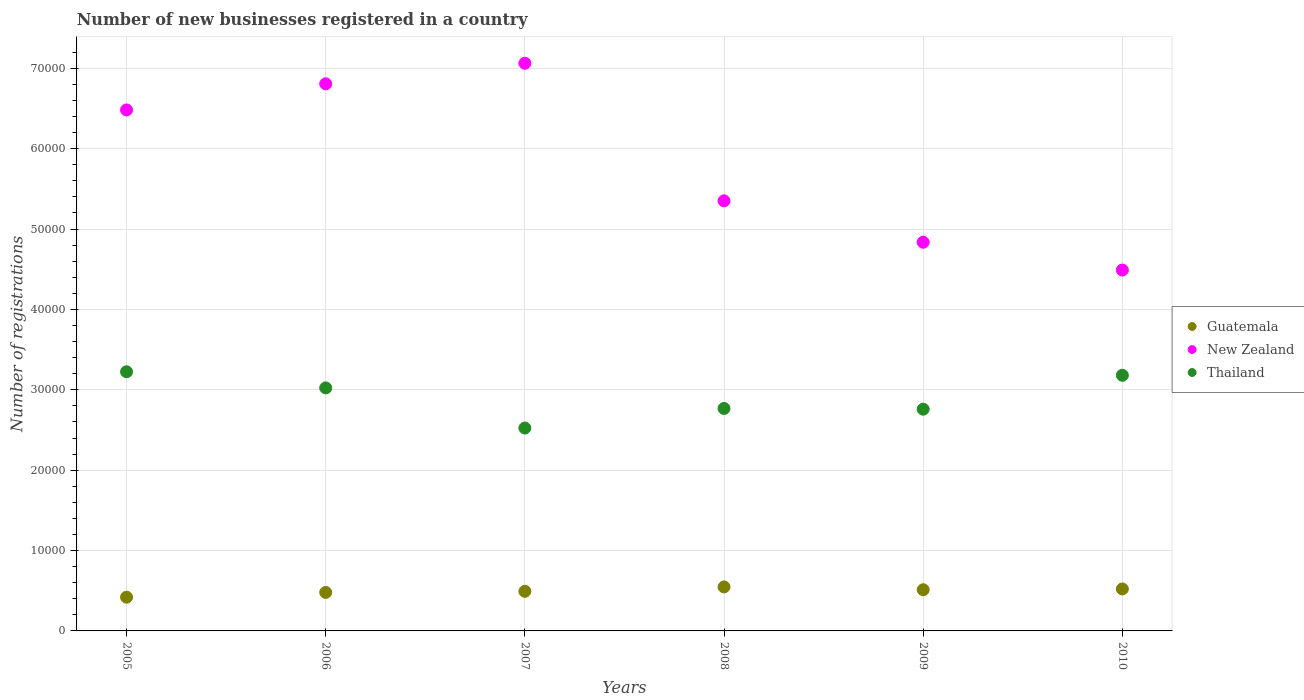How many different coloured dotlines are there?
Give a very brief answer. 3. What is the number of new businesses registered in New Zealand in 2007?
Your answer should be compact. 7.06e+04. Across all years, what is the maximum number of new businesses registered in Thailand?
Offer a very short reply. 3.22e+04. Across all years, what is the minimum number of new businesses registered in New Zealand?
Your answer should be compact. 4.49e+04. In which year was the number of new businesses registered in Thailand minimum?
Offer a terse response. 2007. What is the total number of new businesses registered in New Zealand in the graph?
Your answer should be very brief. 3.50e+05. What is the difference between the number of new businesses registered in Guatemala in 2005 and that in 2007?
Keep it short and to the point. -727. What is the difference between the number of new businesses registered in Thailand in 2010 and the number of new businesses registered in New Zealand in 2008?
Provide a succinct answer. -2.17e+04. What is the average number of new businesses registered in Guatemala per year?
Keep it short and to the point. 4956.17. In the year 2007, what is the difference between the number of new businesses registered in New Zealand and number of new businesses registered in Thailand?
Give a very brief answer. 4.54e+04. What is the ratio of the number of new businesses registered in Guatemala in 2005 to that in 2007?
Your answer should be compact. 0.85. Is the difference between the number of new businesses registered in New Zealand in 2007 and 2010 greater than the difference between the number of new businesses registered in Thailand in 2007 and 2010?
Your answer should be very brief. Yes. What is the difference between the highest and the second highest number of new businesses registered in New Zealand?
Your answer should be compact. 2553. What is the difference between the highest and the lowest number of new businesses registered in Thailand?
Provide a succinct answer. 7002. Is it the case that in every year, the sum of the number of new businesses registered in New Zealand and number of new businesses registered in Thailand  is greater than the number of new businesses registered in Guatemala?
Give a very brief answer. Yes. Does the graph contain any zero values?
Offer a very short reply. No. How are the legend labels stacked?
Give a very brief answer. Vertical. What is the title of the graph?
Offer a terse response. Number of new businesses registered in a country. What is the label or title of the X-axis?
Ensure brevity in your answer.  Years. What is the label or title of the Y-axis?
Ensure brevity in your answer.  Number of registrations. What is the Number of registrations of Guatemala in 2005?
Keep it short and to the point. 4198. What is the Number of registrations in New Zealand in 2005?
Keep it short and to the point. 6.48e+04. What is the Number of registrations of Thailand in 2005?
Make the answer very short. 3.22e+04. What is the Number of registrations of Guatemala in 2006?
Ensure brevity in your answer.  4790. What is the Number of registrations of New Zealand in 2006?
Provide a short and direct response. 6.81e+04. What is the Number of registrations of Thailand in 2006?
Offer a very short reply. 3.02e+04. What is the Number of registrations of Guatemala in 2007?
Ensure brevity in your answer.  4925. What is the Number of registrations of New Zealand in 2007?
Make the answer very short. 7.06e+04. What is the Number of registrations in Thailand in 2007?
Your response must be concise. 2.52e+04. What is the Number of registrations of Guatemala in 2008?
Keep it short and to the point. 5476. What is the Number of registrations in New Zealand in 2008?
Make the answer very short. 5.35e+04. What is the Number of registrations of Thailand in 2008?
Your answer should be compact. 2.77e+04. What is the Number of registrations of Guatemala in 2009?
Your answer should be compact. 5126. What is the Number of registrations in New Zealand in 2009?
Give a very brief answer. 4.84e+04. What is the Number of registrations in Thailand in 2009?
Your response must be concise. 2.76e+04. What is the Number of registrations in Guatemala in 2010?
Ensure brevity in your answer.  5222. What is the Number of registrations of New Zealand in 2010?
Give a very brief answer. 4.49e+04. What is the Number of registrations in Thailand in 2010?
Keep it short and to the point. 3.18e+04. Across all years, what is the maximum Number of registrations in Guatemala?
Make the answer very short. 5476. Across all years, what is the maximum Number of registrations in New Zealand?
Ensure brevity in your answer.  7.06e+04. Across all years, what is the maximum Number of registrations in Thailand?
Your answer should be very brief. 3.22e+04. Across all years, what is the minimum Number of registrations in Guatemala?
Offer a terse response. 4198. Across all years, what is the minimum Number of registrations of New Zealand?
Provide a short and direct response. 4.49e+04. Across all years, what is the minimum Number of registrations in Thailand?
Keep it short and to the point. 2.52e+04. What is the total Number of registrations in Guatemala in the graph?
Your answer should be compact. 2.97e+04. What is the total Number of registrations in New Zealand in the graph?
Offer a very short reply. 3.50e+05. What is the total Number of registrations in Thailand in the graph?
Give a very brief answer. 1.75e+05. What is the difference between the Number of registrations in Guatemala in 2005 and that in 2006?
Your answer should be compact. -592. What is the difference between the Number of registrations in New Zealand in 2005 and that in 2006?
Make the answer very short. -3253. What is the difference between the Number of registrations of Thailand in 2005 and that in 2006?
Make the answer very short. 2008. What is the difference between the Number of registrations of Guatemala in 2005 and that in 2007?
Offer a terse response. -727. What is the difference between the Number of registrations in New Zealand in 2005 and that in 2007?
Offer a terse response. -5806. What is the difference between the Number of registrations of Thailand in 2005 and that in 2007?
Offer a very short reply. 7002. What is the difference between the Number of registrations of Guatemala in 2005 and that in 2008?
Make the answer very short. -1278. What is the difference between the Number of registrations of New Zealand in 2005 and that in 2008?
Ensure brevity in your answer.  1.13e+04. What is the difference between the Number of registrations of Thailand in 2005 and that in 2008?
Ensure brevity in your answer.  4563. What is the difference between the Number of registrations of Guatemala in 2005 and that in 2009?
Offer a very short reply. -928. What is the difference between the Number of registrations in New Zealand in 2005 and that in 2009?
Provide a short and direct response. 1.65e+04. What is the difference between the Number of registrations in Thailand in 2005 and that in 2009?
Provide a short and direct response. 4656. What is the difference between the Number of registrations of Guatemala in 2005 and that in 2010?
Ensure brevity in your answer.  -1024. What is the difference between the Number of registrations of New Zealand in 2005 and that in 2010?
Make the answer very short. 1.99e+04. What is the difference between the Number of registrations of Thailand in 2005 and that in 2010?
Make the answer very short. 437. What is the difference between the Number of registrations of Guatemala in 2006 and that in 2007?
Your answer should be very brief. -135. What is the difference between the Number of registrations of New Zealand in 2006 and that in 2007?
Provide a succinct answer. -2553. What is the difference between the Number of registrations in Thailand in 2006 and that in 2007?
Your answer should be compact. 4994. What is the difference between the Number of registrations in Guatemala in 2006 and that in 2008?
Offer a very short reply. -686. What is the difference between the Number of registrations of New Zealand in 2006 and that in 2008?
Offer a very short reply. 1.46e+04. What is the difference between the Number of registrations of Thailand in 2006 and that in 2008?
Your answer should be very brief. 2555. What is the difference between the Number of registrations of Guatemala in 2006 and that in 2009?
Offer a very short reply. -336. What is the difference between the Number of registrations in New Zealand in 2006 and that in 2009?
Provide a short and direct response. 1.97e+04. What is the difference between the Number of registrations in Thailand in 2006 and that in 2009?
Provide a succinct answer. 2648. What is the difference between the Number of registrations of Guatemala in 2006 and that in 2010?
Keep it short and to the point. -432. What is the difference between the Number of registrations of New Zealand in 2006 and that in 2010?
Your answer should be compact. 2.32e+04. What is the difference between the Number of registrations in Thailand in 2006 and that in 2010?
Provide a succinct answer. -1571. What is the difference between the Number of registrations of Guatemala in 2007 and that in 2008?
Ensure brevity in your answer.  -551. What is the difference between the Number of registrations in New Zealand in 2007 and that in 2008?
Ensure brevity in your answer.  1.71e+04. What is the difference between the Number of registrations in Thailand in 2007 and that in 2008?
Make the answer very short. -2439. What is the difference between the Number of registrations of Guatemala in 2007 and that in 2009?
Give a very brief answer. -201. What is the difference between the Number of registrations of New Zealand in 2007 and that in 2009?
Give a very brief answer. 2.23e+04. What is the difference between the Number of registrations in Thailand in 2007 and that in 2009?
Your answer should be very brief. -2346. What is the difference between the Number of registrations in Guatemala in 2007 and that in 2010?
Ensure brevity in your answer.  -297. What is the difference between the Number of registrations of New Zealand in 2007 and that in 2010?
Give a very brief answer. 2.57e+04. What is the difference between the Number of registrations in Thailand in 2007 and that in 2010?
Your answer should be very brief. -6565. What is the difference between the Number of registrations of Guatemala in 2008 and that in 2009?
Give a very brief answer. 350. What is the difference between the Number of registrations in New Zealand in 2008 and that in 2009?
Make the answer very short. 5154. What is the difference between the Number of registrations in Thailand in 2008 and that in 2009?
Your response must be concise. 93. What is the difference between the Number of registrations of Guatemala in 2008 and that in 2010?
Keep it short and to the point. 254. What is the difference between the Number of registrations of New Zealand in 2008 and that in 2010?
Give a very brief answer. 8614. What is the difference between the Number of registrations in Thailand in 2008 and that in 2010?
Give a very brief answer. -4126. What is the difference between the Number of registrations of Guatemala in 2009 and that in 2010?
Make the answer very short. -96. What is the difference between the Number of registrations of New Zealand in 2009 and that in 2010?
Your response must be concise. 3460. What is the difference between the Number of registrations of Thailand in 2009 and that in 2010?
Your response must be concise. -4219. What is the difference between the Number of registrations in Guatemala in 2005 and the Number of registrations in New Zealand in 2006?
Make the answer very short. -6.39e+04. What is the difference between the Number of registrations in Guatemala in 2005 and the Number of registrations in Thailand in 2006?
Your answer should be very brief. -2.60e+04. What is the difference between the Number of registrations in New Zealand in 2005 and the Number of registrations in Thailand in 2006?
Give a very brief answer. 3.46e+04. What is the difference between the Number of registrations in Guatemala in 2005 and the Number of registrations in New Zealand in 2007?
Offer a terse response. -6.64e+04. What is the difference between the Number of registrations of Guatemala in 2005 and the Number of registrations of Thailand in 2007?
Ensure brevity in your answer.  -2.10e+04. What is the difference between the Number of registrations of New Zealand in 2005 and the Number of registrations of Thailand in 2007?
Your response must be concise. 3.96e+04. What is the difference between the Number of registrations in Guatemala in 2005 and the Number of registrations in New Zealand in 2008?
Make the answer very short. -4.93e+04. What is the difference between the Number of registrations in Guatemala in 2005 and the Number of registrations in Thailand in 2008?
Your answer should be compact. -2.35e+04. What is the difference between the Number of registrations of New Zealand in 2005 and the Number of registrations of Thailand in 2008?
Keep it short and to the point. 3.71e+04. What is the difference between the Number of registrations in Guatemala in 2005 and the Number of registrations in New Zealand in 2009?
Keep it short and to the point. -4.42e+04. What is the difference between the Number of registrations of Guatemala in 2005 and the Number of registrations of Thailand in 2009?
Your answer should be very brief. -2.34e+04. What is the difference between the Number of registrations in New Zealand in 2005 and the Number of registrations in Thailand in 2009?
Provide a succinct answer. 3.72e+04. What is the difference between the Number of registrations of Guatemala in 2005 and the Number of registrations of New Zealand in 2010?
Your answer should be compact. -4.07e+04. What is the difference between the Number of registrations in Guatemala in 2005 and the Number of registrations in Thailand in 2010?
Offer a very short reply. -2.76e+04. What is the difference between the Number of registrations of New Zealand in 2005 and the Number of registrations of Thailand in 2010?
Ensure brevity in your answer.  3.30e+04. What is the difference between the Number of registrations of Guatemala in 2006 and the Number of registrations of New Zealand in 2007?
Your answer should be very brief. -6.58e+04. What is the difference between the Number of registrations in Guatemala in 2006 and the Number of registrations in Thailand in 2007?
Provide a short and direct response. -2.05e+04. What is the difference between the Number of registrations in New Zealand in 2006 and the Number of registrations in Thailand in 2007?
Ensure brevity in your answer.  4.28e+04. What is the difference between the Number of registrations of Guatemala in 2006 and the Number of registrations of New Zealand in 2008?
Your answer should be very brief. -4.87e+04. What is the difference between the Number of registrations in Guatemala in 2006 and the Number of registrations in Thailand in 2008?
Your response must be concise. -2.29e+04. What is the difference between the Number of registrations in New Zealand in 2006 and the Number of registrations in Thailand in 2008?
Offer a terse response. 4.04e+04. What is the difference between the Number of registrations in Guatemala in 2006 and the Number of registrations in New Zealand in 2009?
Provide a succinct answer. -4.36e+04. What is the difference between the Number of registrations of Guatemala in 2006 and the Number of registrations of Thailand in 2009?
Your answer should be very brief. -2.28e+04. What is the difference between the Number of registrations in New Zealand in 2006 and the Number of registrations in Thailand in 2009?
Provide a short and direct response. 4.05e+04. What is the difference between the Number of registrations of Guatemala in 2006 and the Number of registrations of New Zealand in 2010?
Give a very brief answer. -4.01e+04. What is the difference between the Number of registrations in Guatemala in 2006 and the Number of registrations in Thailand in 2010?
Provide a short and direct response. -2.70e+04. What is the difference between the Number of registrations of New Zealand in 2006 and the Number of registrations of Thailand in 2010?
Make the answer very short. 3.63e+04. What is the difference between the Number of registrations of Guatemala in 2007 and the Number of registrations of New Zealand in 2008?
Your response must be concise. -4.86e+04. What is the difference between the Number of registrations of Guatemala in 2007 and the Number of registrations of Thailand in 2008?
Keep it short and to the point. -2.28e+04. What is the difference between the Number of registrations in New Zealand in 2007 and the Number of registrations in Thailand in 2008?
Provide a short and direct response. 4.29e+04. What is the difference between the Number of registrations of Guatemala in 2007 and the Number of registrations of New Zealand in 2009?
Your answer should be compact. -4.34e+04. What is the difference between the Number of registrations of Guatemala in 2007 and the Number of registrations of Thailand in 2009?
Your response must be concise. -2.27e+04. What is the difference between the Number of registrations in New Zealand in 2007 and the Number of registrations in Thailand in 2009?
Give a very brief answer. 4.30e+04. What is the difference between the Number of registrations in Guatemala in 2007 and the Number of registrations in New Zealand in 2010?
Offer a very short reply. -4.00e+04. What is the difference between the Number of registrations of Guatemala in 2007 and the Number of registrations of Thailand in 2010?
Ensure brevity in your answer.  -2.69e+04. What is the difference between the Number of registrations of New Zealand in 2007 and the Number of registrations of Thailand in 2010?
Provide a succinct answer. 3.88e+04. What is the difference between the Number of registrations of Guatemala in 2008 and the Number of registrations of New Zealand in 2009?
Offer a terse response. -4.29e+04. What is the difference between the Number of registrations in Guatemala in 2008 and the Number of registrations in Thailand in 2009?
Give a very brief answer. -2.21e+04. What is the difference between the Number of registrations in New Zealand in 2008 and the Number of registrations in Thailand in 2009?
Provide a short and direct response. 2.59e+04. What is the difference between the Number of registrations in Guatemala in 2008 and the Number of registrations in New Zealand in 2010?
Your response must be concise. -3.94e+04. What is the difference between the Number of registrations of Guatemala in 2008 and the Number of registrations of Thailand in 2010?
Your answer should be compact. -2.63e+04. What is the difference between the Number of registrations in New Zealand in 2008 and the Number of registrations in Thailand in 2010?
Keep it short and to the point. 2.17e+04. What is the difference between the Number of registrations in Guatemala in 2009 and the Number of registrations in New Zealand in 2010?
Provide a succinct answer. -3.98e+04. What is the difference between the Number of registrations of Guatemala in 2009 and the Number of registrations of Thailand in 2010?
Make the answer very short. -2.67e+04. What is the difference between the Number of registrations of New Zealand in 2009 and the Number of registrations of Thailand in 2010?
Keep it short and to the point. 1.66e+04. What is the average Number of registrations of Guatemala per year?
Offer a terse response. 4956.17. What is the average Number of registrations in New Zealand per year?
Ensure brevity in your answer.  5.84e+04. What is the average Number of registrations of Thailand per year?
Your answer should be compact. 2.91e+04. In the year 2005, what is the difference between the Number of registrations in Guatemala and Number of registrations in New Zealand?
Offer a very short reply. -6.06e+04. In the year 2005, what is the difference between the Number of registrations of Guatemala and Number of registrations of Thailand?
Your response must be concise. -2.80e+04. In the year 2005, what is the difference between the Number of registrations in New Zealand and Number of registrations in Thailand?
Your response must be concise. 3.26e+04. In the year 2006, what is the difference between the Number of registrations in Guatemala and Number of registrations in New Zealand?
Your response must be concise. -6.33e+04. In the year 2006, what is the difference between the Number of registrations in Guatemala and Number of registrations in Thailand?
Offer a terse response. -2.54e+04. In the year 2006, what is the difference between the Number of registrations of New Zealand and Number of registrations of Thailand?
Your answer should be very brief. 3.78e+04. In the year 2007, what is the difference between the Number of registrations of Guatemala and Number of registrations of New Zealand?
Ensure brevity in your answer.  -6.57e+04. In the year 2007, what is the difference between the Number of registrations in Guatemala and Number of registrations in Thailand?
Keep it short and to the point. -2.03e+04. In the year 2007, what is the difference between the Number of registrations of New Zealand and Number of registrations of Thailand?
Make the answer very short. 4.54e+04. In the year 2008, what is the difference between the Number of registrations in Guatemala and Number of registrations in New Zealand?
Keep it short and to the point. -4.80e+04. In the year 2008, what is the difference between the Number of registrations in Guatemala and Number of registrations in Thailand?
Offer a terse response. -2.22e+04. In the year 2008, what is the difference between the Number of registrations of New Zealand and Number of registrations of Thailand?
Your response must be concise. 2.58e+04. In the year 2009, what is the difference between the Number of registrations of Guatemala and Number of registrations of New Zealand?
Give a very brief answer. -4.32e+04. In the year 2009, what is the difference between the Number of registrations of Guatemala and Number of registrations of Thailand?
Offer a terse response. -2.25e+04. In the year 2009, what is the difference between the Number of registrations of New Zealand and Number of registrations of Thailand?
Provide a succinct answer. 2.08e+04. In the year 2010, what is the difference between the Number of registrations of Guatemala and Number of registrations of New Zealand?
Offer a terse response. -3.97e+04. In the year 2010, what is the difference between the Number of registrations of Guatemala and Number of registrations of Thailand?
Provide a short and direct response. -2.66e+04. In the year 2010, what is the difference between the Number of registrations in New Zealand and Number of registrations in Thailand?
Your response must be concise. 1.31e+04. What is the ratio of the Number of registrations in Guatemala in 2005 to that in 2006?
Offer a terse response. 0.88. What is the ratio of the Number of registrations of New Zealand in 2005 to that in 2006?
Keep it short and to the point. 0.95. What is the ratio of the Number of registrations in Thailand in 2005 to that in 2006?
Give a very brief answer. 1.07. What is the ratio of the Number of registrations of Guatemala in 2005 to that in 2007?
Your response must be concise. 0.85. What is the ratio of the Number of registrations in New Zealand in 2005 to that in 2007?
Offer a terse response. 0.92. What is the ratio of the Number of registrations in Thailand in 2005 to that in 2007?
Ensure brevity in your answer.  1.28. What is the ratio of the Number of registrations in Guatemala in 2005 to that in 2008?
Offer a very short reply. 0.77. What is the ratio of the Number of registrations in New Zealand in 2005 to that in 2008?
Offer a very short reply. 1.21. What is the ratio of the Number of registrations in Thailand in 2005 to that in 2008?
Your answer should be very brief. 1.16. What is the ratio of the Number of registrations of Guatemala in 2005 to that in 2009?
Keep it short and to the point. 0.82. What is the ratio of the Number of registrations in New Zealand in 2005 to that in 2009?
Offer a terse response. 1.34. What is the ratio of the Number of registrations in Thailand in 2005 to that in 2009?
Offer a very short reply. 1.17. What is the ratio of the Number of registrations of Guatemala in 2005 to that in 2010?
Your response must be concise. 0.8. What is the ratio of the Number of registrations in New Zealand in 2005 to that in 2010?
Offer a very short reply. 1.44. What is the ratio of the Number of registrations in Thailand in 2005 to that in 2010?
Your response must be concise. 1.01. What is the ratio of the Number of registrations of Guatemala in 2006 to that in 2007?
Your answer should be very brief. 0.97. What is the ratio of the Number of registrations of New Zealand in 2006 to that in 2007?
Provide a short and direct response. 0.96. What is the ratio of the Number of registrations of Thailand in 2006 to that in 2007?
Provide a short and direct response. 1.2. What is the ratio of the Number of registrations in Guatemala in 2006 to that in 2008?
Offer a terse response. 0.87. What is the ratio of the Number of registrations of New Zealand in 2006 to that in 2008?
Keep it short and to the point. 1.27. What is the ratio of the Number of registrations in Thailand in 2006 to that in 2008?
Your answer should be compact. 1.09. What is the ratio of the Number of registrations of Guatemala in 2006 to that in 2009?
Keep it short and to the point. 0.93. What is the ratio of the Number of registrations in New Zealand in 2006 to that in 2009?
Offer a very short reply. 1.41. What is the ratio of the Number of registrations of Thailand in 2006 to that in 2009?
Your answer should be very brief. 1.1. What is the ratio of the Number of registrations in Guatemala in 2006 to that in 2010?
Keep it short and to the point. 0.92. What is the ratio of the Number of registrations of New Zealand in 2006 to that in 2010?
Your response must be concise. 1.52. What is the ratio of the Number of registrations of Thailand in 2006 to that in 2010?
Offer a very short reply. 0.95. What is the ratio of the Number of registrations in Guatemala in 2007 to that in 2008?
Your response must be concise. 0.9. What is the ratio of the Number of registrations of New Zealand in 2007 to that in 2008?
Your answer should be compact. 1.32. What is the ratio of the Number of registrations of Thailand in 2007 to that in 2008?
Your answer should be compact. 0.91. What is the ratio of the Number of registrations of Guatemala in 2007 to that in 2009?
Provide a short and direct response. 0.96. What is the ratio of the Number of registrations in New Zealand in 2007 to that in 2009?
Your answer should be very brief. 1.46. What is the ratio of the Number of registrations in Thailand in 2007 to that in 2009?
Ensure brevity in your answer.  0.92. What is the ratio of the Number of registrations of Guatemala in 2007 to that in 2010?
Your answer should be very brief. 0.94. What is the ratio of the Number of registrations of New Zealand in 2007 to that in 2010?
Your answer should be very brief. 1.57. What is the ratio of the Number of registrations in Thailand in 2007 to that in 2010?
Give a very brief answer. 0.79. What is the ratio of the Number of registrations in Guatemala in 2008 to that in 2009?
Your answer should be very brief. 1.07. What is the ratio of the Number of registrations of New Zealand in 2008 to that in 2009?
Give a very brief answer. 1.11. What is the ratio of the Number of registrations in Guatemala in 2008 to that in 2010?
Provide a succinct answer. 1.05. What is the ratio of the Number of registrations in New Zealand in 2008 to that in 2010?
Your answer should be compact. 1.19. What is the ratio of the Number of registrations in Thailand in 2008 to that in 2010?
Give a very brief answer. 0.87. What is the ratio of the Number of registrations of Guatemala in 2009 to that in 2010?
Provide a succinct answer. 0.98. What is the ratio of the Number of registrations of New Zealand in 2009 to that in 2010?
Ensure brevity in your answer.  1.08. What is the ratio of the Number of registrations in Thailand in 2009 to that in 2010?
Keep it short and to the point. 0.87. What is the difference between the highest and the second highest Number of registrations in Guatemala?
Provide a short and direct response. 254. What is the difference between the highest and the second highest Number of registrations of New Zealand?
Offer a terse response. 2553. What is the difference between the highest and the second highest Number of registrations in Thailand?
Keep it short and to the point. 437. What is the difference between the highest and the lowest Number of registrations in Guatemala?
Ensure brevity in your answer.  1278. What is the difference between the highest and the lowest Number of registrations of New Zealand?
Ensure brevity in your answer.  2.57e+04. What is the difference between the highest and the lowest Number of registrations of Thailand?
Offer a terse response. 7002. 